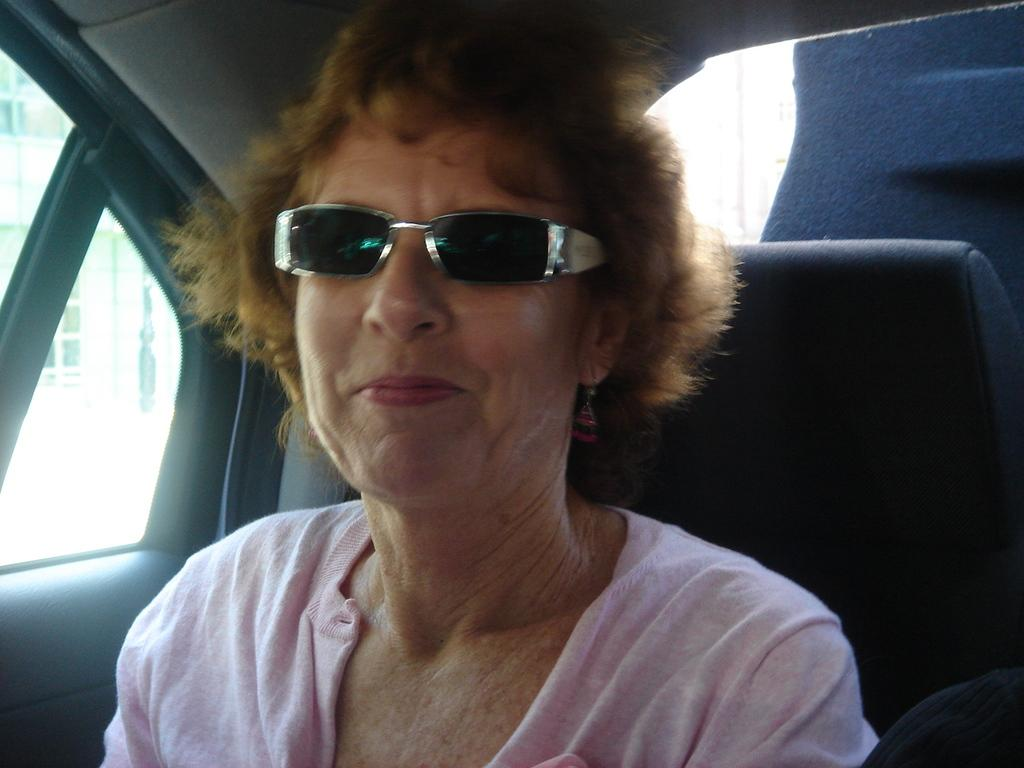What is the person in the image doing? The person is sitting inside a vehicle. What is the person wearing? The person is wearing a pink dress. What can be seen in the background of the image? There is a building visible in the background. How many books does the carpenter feel ashamed about in the image? There is no carpenter or books present in the image, so it is not possible to determine any feelings of shame related to books. 